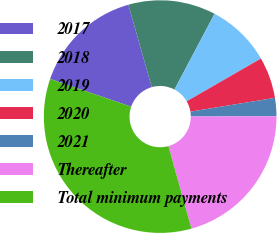Convert chart. <chart><loc_0><loc_0><loc_500><loc_500><pie_chart><fcel>2017<fcel>2018<fcel>2019<fcel>2020<fcel>2021<fcel>Thereafter<fcel>Total minimum payments<nl><fcel>15.35%<fcel>12.15%<fcel>8.94%<fcel>5.74%<fcel>2.53%<fcel>20.71%<fcel>34.58%<nl></chart> 